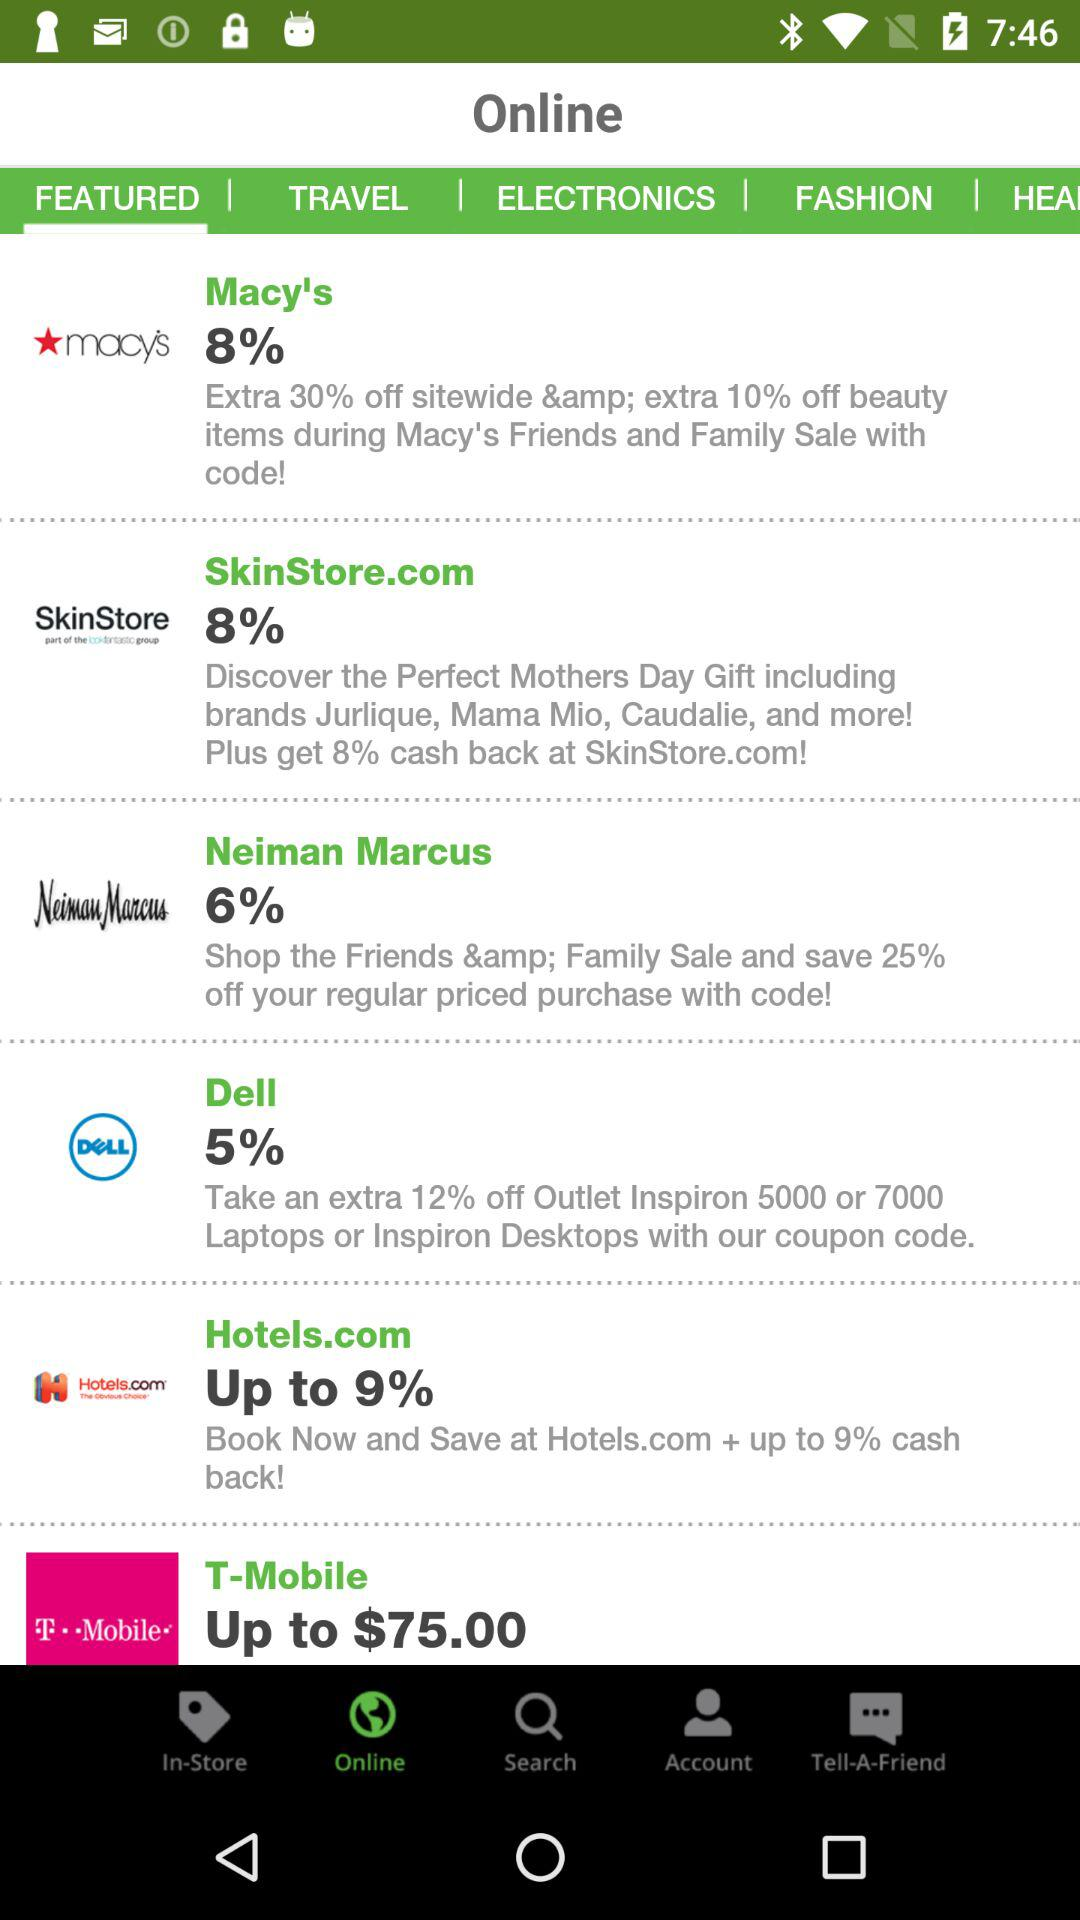How much cashback does "Hotels.com" offer? "Hotels.com" offers a cashback of up to 9%. 